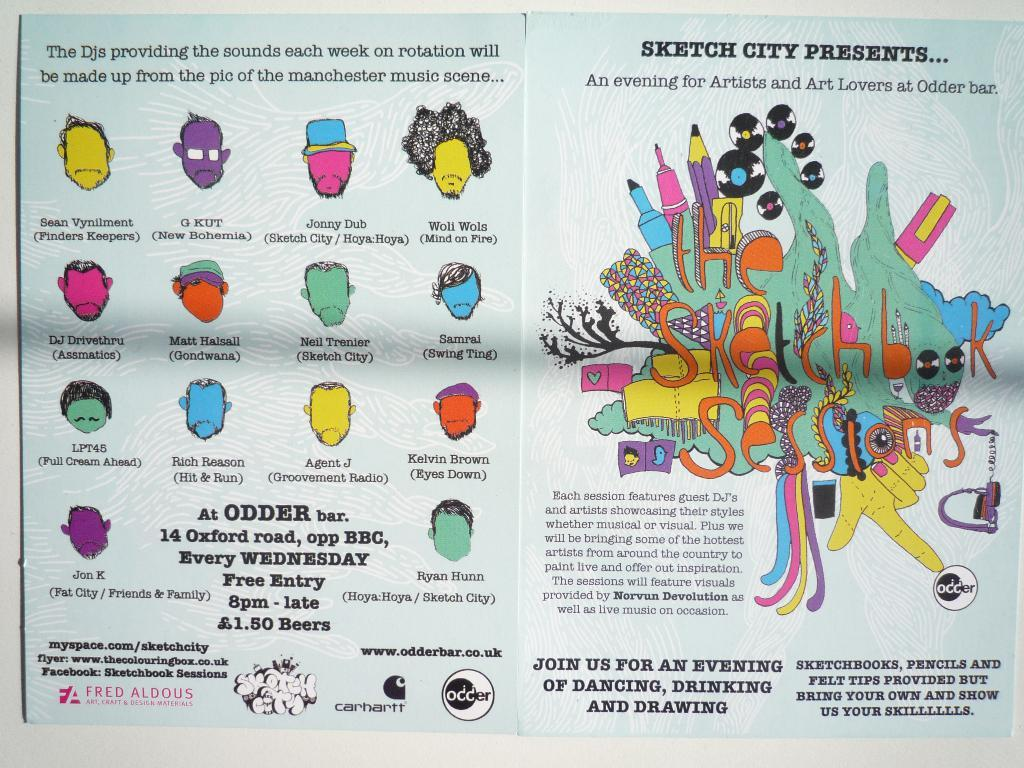<image>
Relay a brief, clear account of the picture shown. A poster promotes an event at a place called SKETCH CITY. 